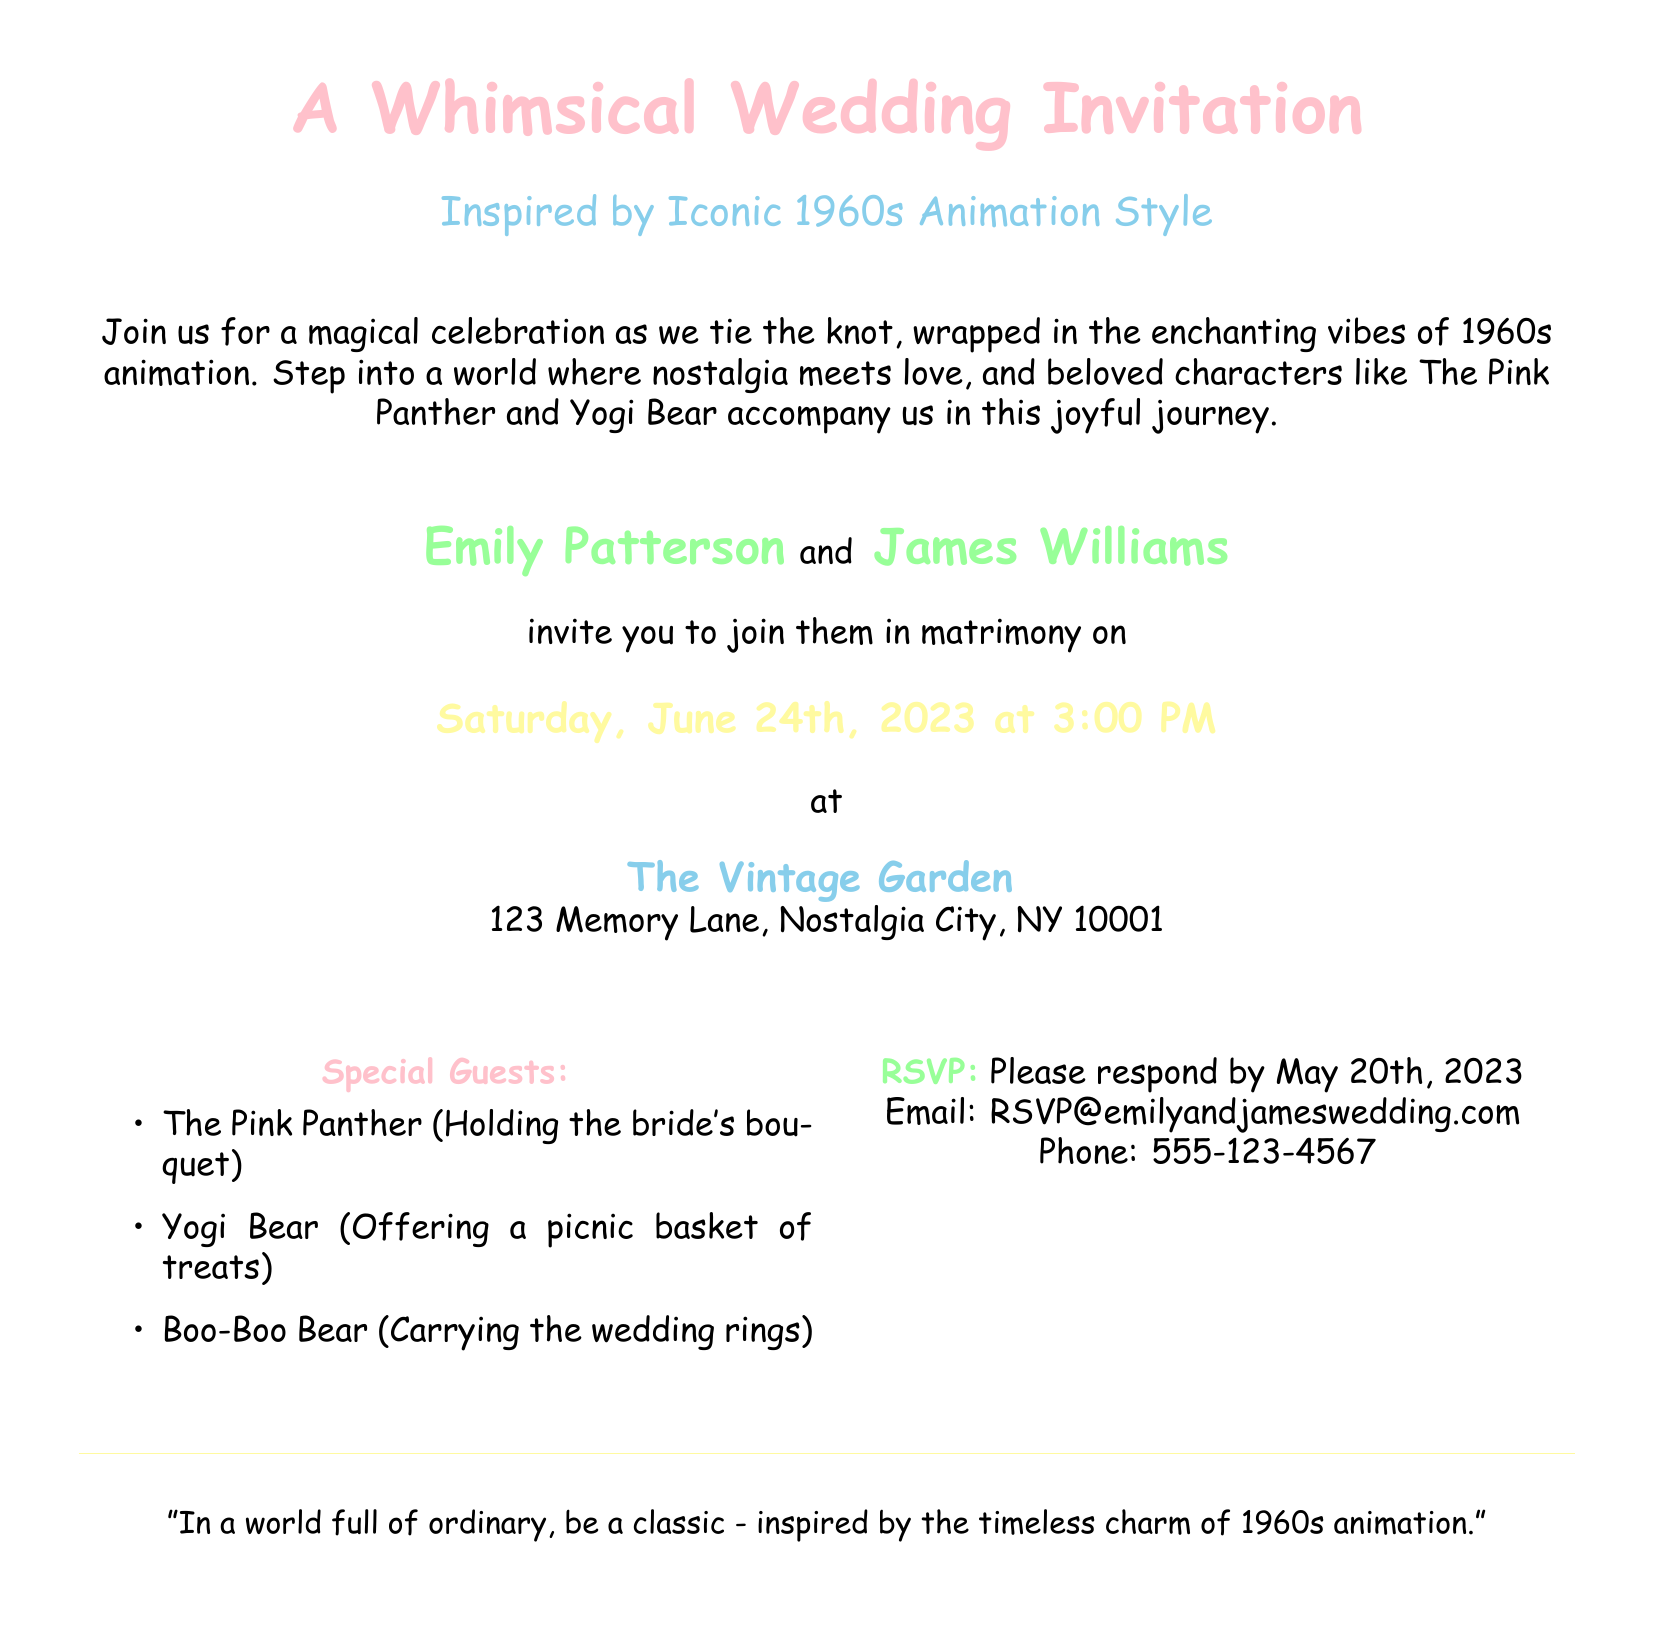What is the date of the wedding? The document states the wedding date in a highlighted section, which is "Saturday, June 24th, 2023".
Answer: Saturday, June 24th, 2023 Who are the bride and groom? The names of the bride and groom are listed in the invitation, which are "Emily Patterson" and "James Williams".
Answer: Emily Patterson and James Williams What is the venue name? The invitation specifies the venue as "The Vintage Garden".
Answer: The Vintage Garden What time does the wedding start? The time for the wedding ceremony is indicated as "3:00 PM".
Answer: 3:00 PM By when should guests RSVP? The RSVP deadline is explicitly mentioned as "May 20th, 2023".
Answer: May 20th, 2023 Which character is holding the bride's bouquet? The character mentioned in a special guest list holding the bride's bouquet is "The Pink Panther".
Answer: The Pink Panther What is the color motif of the wedding invitation? The colors used prominently in the invitation include pink, blue, yellow, and green, reflecting a whimsical style, particularly associated with pop art.
Answer: Pink, blue, yellow, and green What is the theme of the wedding invitation? The theme is described as being inspired by "Iconic 1960s Animation Style".
Answer: Iconic 1960s Animation Style What is a notable quote featured in the invitation? The invitation includes a quote that says, "In a world full of ordinary, be a classic - inspired by the timeless charm of 1960s animation."
Answer: "In a world full of ordinary, be a classic - inspired by the timeless charm of 1960s animation." 